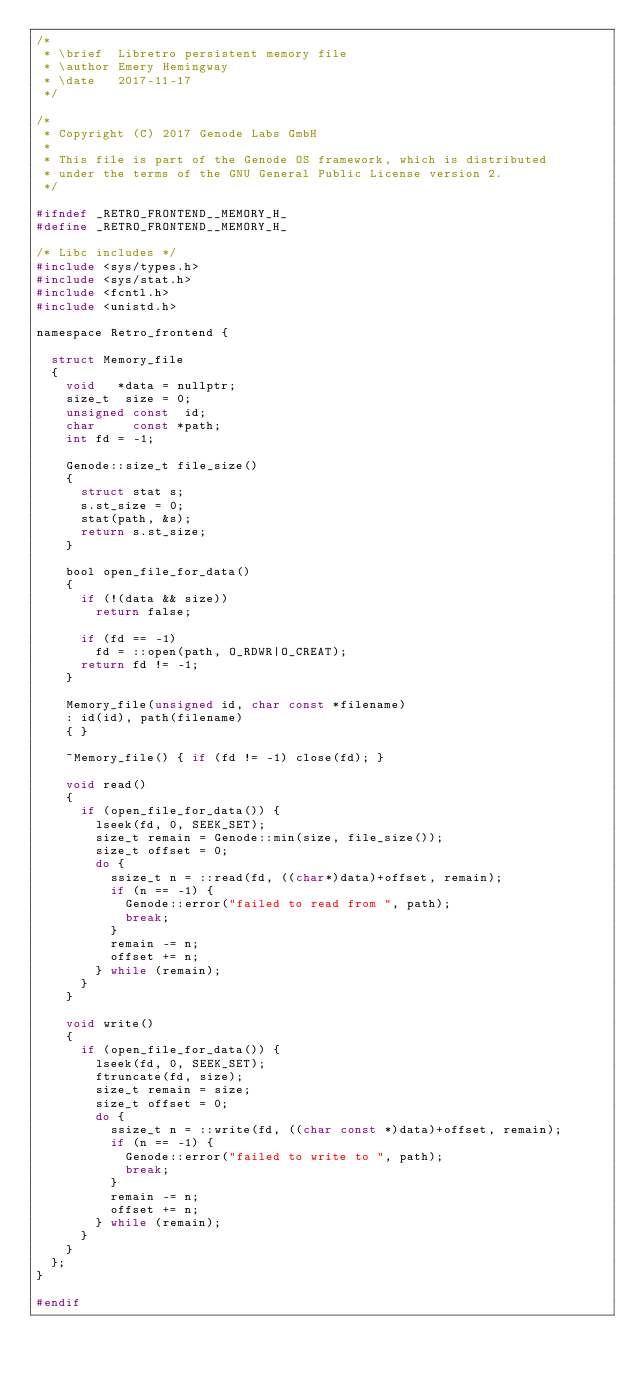Convert code to text. <code><loc_0><loc_0><loc_500><loc_500><_C_>/*
 * \brief  Libretro persistent memory file
 * \author Emery Hemingway
 * \date   2017-11-17
 */

/*
 * Copyright (C) 2017 Genode Labs GmbH
 *
 * This file is part of the Genode OS framework, which is distributed
 * under the terms of the GNU General Public License version 2.
 */

#ifndef _RETRO_FRONTEND__MEMORY_H_
#define _RETRO_FRONTEND__MEMORY_H_

/* Libc includes */
#include <sys/types.h>
#include <sys/stat.h>
#include <fcntl.h>
#include <unistd.h>

namespace Retro_frontend {

	struct Memory_file
	{
		void   *data = nullptr;
		size_t  size = 0;
		unsigned const  id;
		char     const *path;
		int fd = -1;

		Genode::size_t file_size()
		{
			struct stat s;
			s.st_size = 0;
			stat(path, &s);
			return s.st_size;
		}

		bool open_file_for_data()
		{
			if (!(data && size))
				return false;

			if (fd == -1)
				fd = ::open(path, O_RDWR|O_CREAT);
			return fd != -1;
		}

		Memory_file(unsigned id, char const *filename)
		: id(id), path(filename)
		{ }

		~Memory_file() { if (fd != -1) close(fd); }

		void read()
		{
			if (open_file_for_data()) {
				lseek(fd, 0, SEEK_SET);
				size_t remain = Genode::min(size, file_size());
				size_t offset = 0;
				do {
					ssize_t n = ::read(fd, ((char*)data)+offset, remain);
					if (n == -1) {
						Genode::error("failed to read from ", path);
						break;
					}
					remain -= n;
					offset += n;
				} while (remain);
			}
		}

		void write()
		{
			if (open_file_for_data()) {
				lseek(fd, 0, SEEK_SET);
				ftruncate(fd, size);
				size_t remain = size;
				size_t offset = 0;
				do {
					ssize_t n = ::write(fd, ((char const *)data)+offset, remain);
					if (n == -1) {
						Genode::error("failed to write to ", path);
						break;
					}
					remain -= n;
					offset += n;
				} while (remain);
			}
		}
	};
}

#endif
</code> 